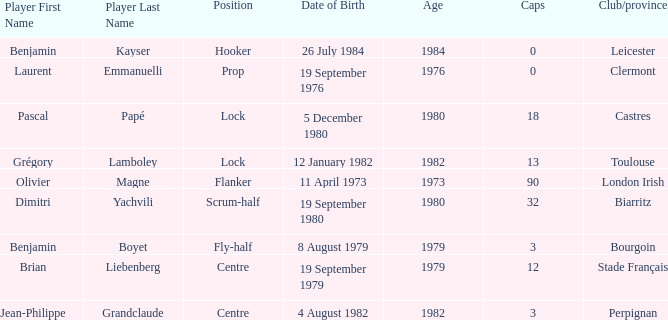What is the geographical placement of perpignan? Centre. 